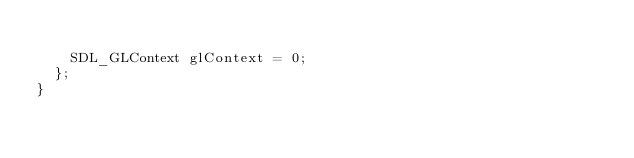<code> <loc_0><loc_0><loc_500><loc_500><_C_>
		SDL_GLContext glContext = 0;
	};
}
</code> 